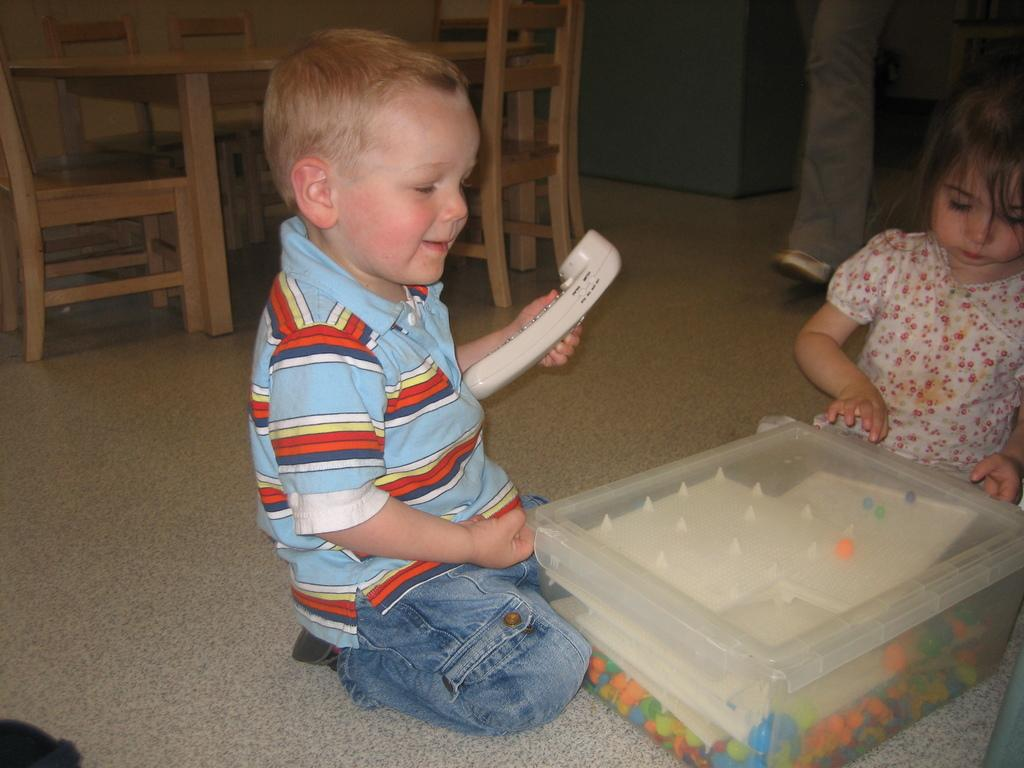How many kids are in the image? There are two kids in the image. What is between the two kids? There is a box between the two kids. What can be seen in the background of the image? There is a table in the background of the image. What furniture is around the table in the background? Chairs are present around the table in the background. What type of sign can be seen on the table in the image? There is no sign present on the table in the image. 